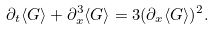<formula> <loc_0><loc_0><loc_500><loc_500>\partial _ { t } \langle G \rangle + \partial _ { x } ^ { 3 } \langle G \rangle = 3 ( \partial _ { x } \langle G \rangle ) ^ { 2 } .</formula> 